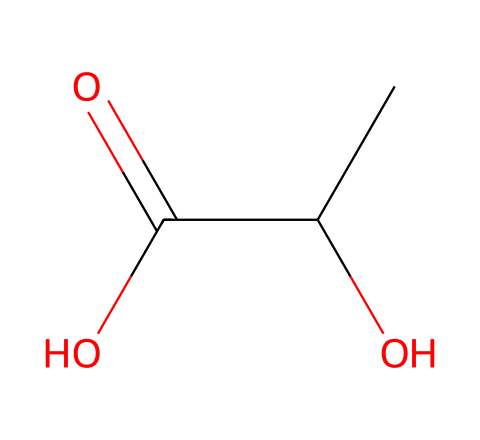What is the common name of this chemical? The chemical structure corresponds to lactic acid, which is commonly known as milk acid or 2-hydroxypropanoic acid.
Answer: lactic acid How many carbon atoms are present in this structure? The SMILES representation shows 'CC', indicating there are two carbon atoms in a row, along with one additional carbon in the carboxylic acid functional group, totaling three carbon atoms.
Answer: three What type of functional groups are present in lactic acid? The structure includes a hydroxyl group (-OH) and a carboxylic acid group (-COOH), which are identified by the presence of the 'O' and the '=' sign in the formula.
Answer: hydroxyl and carboxylic acid Is this compound chiral? The structure has a chiral center at the second carbon (C) because it has four different groups attached to it: a hydrogen atom, a hydroxyl group, a carboxylic acid, and a propane group.
Answer: yes What is the molecular formula for lactic acid? To determine the molecular formula, count the atoms: three carbons (C), six hydrogens (H), and two oxygens (O), leading to the formula C3H6O3.
Answer: C3H6O3 How many hydrogen bonds can lactic acid form? The presence of one hydroxyl group and one carboxylic group allows lactic acid to form multiple hydrogen bonds, particularly two effective hydrogen bonds.
Answer: two What type of isomerism does lactic acid exhibit? Lactic acid exhibits optical isomerism because it has a chiral center and can exist in two enantiomeric forms that are mirror images of each other.
Answer: optical isomerism 